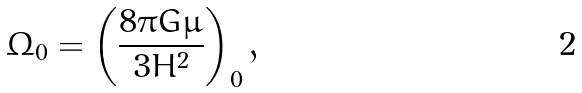<formula> <loc_0><loc_0><loc_500><loc_500>\Omega _ { 0 } = \left ( \frac { 8 \pi G \mu } { 3 H ^ { 2 } } \right ) _ { 0 } ,</formula> 